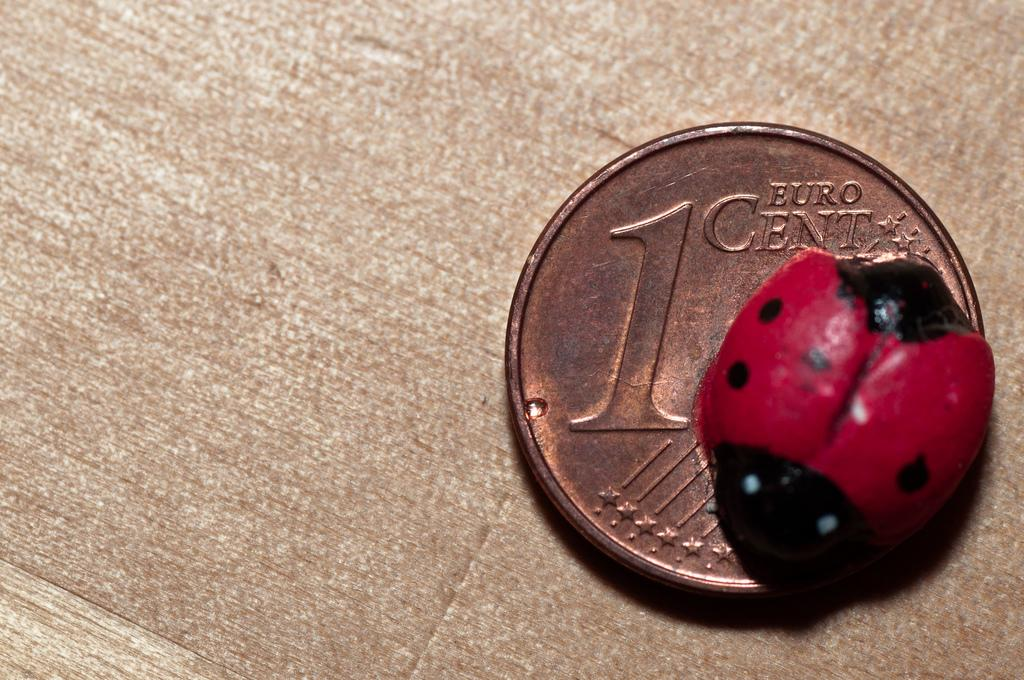What object can be seen in the image that is typically used for monetary transactions? There is a coin in the image that is typically used for monetary transactions. What small creature can be seen in the image? There is a bug in the image. What type of drink is being consumed by the frog in the image? There is no frog present in the image, and therefore no such activity can be observed. 